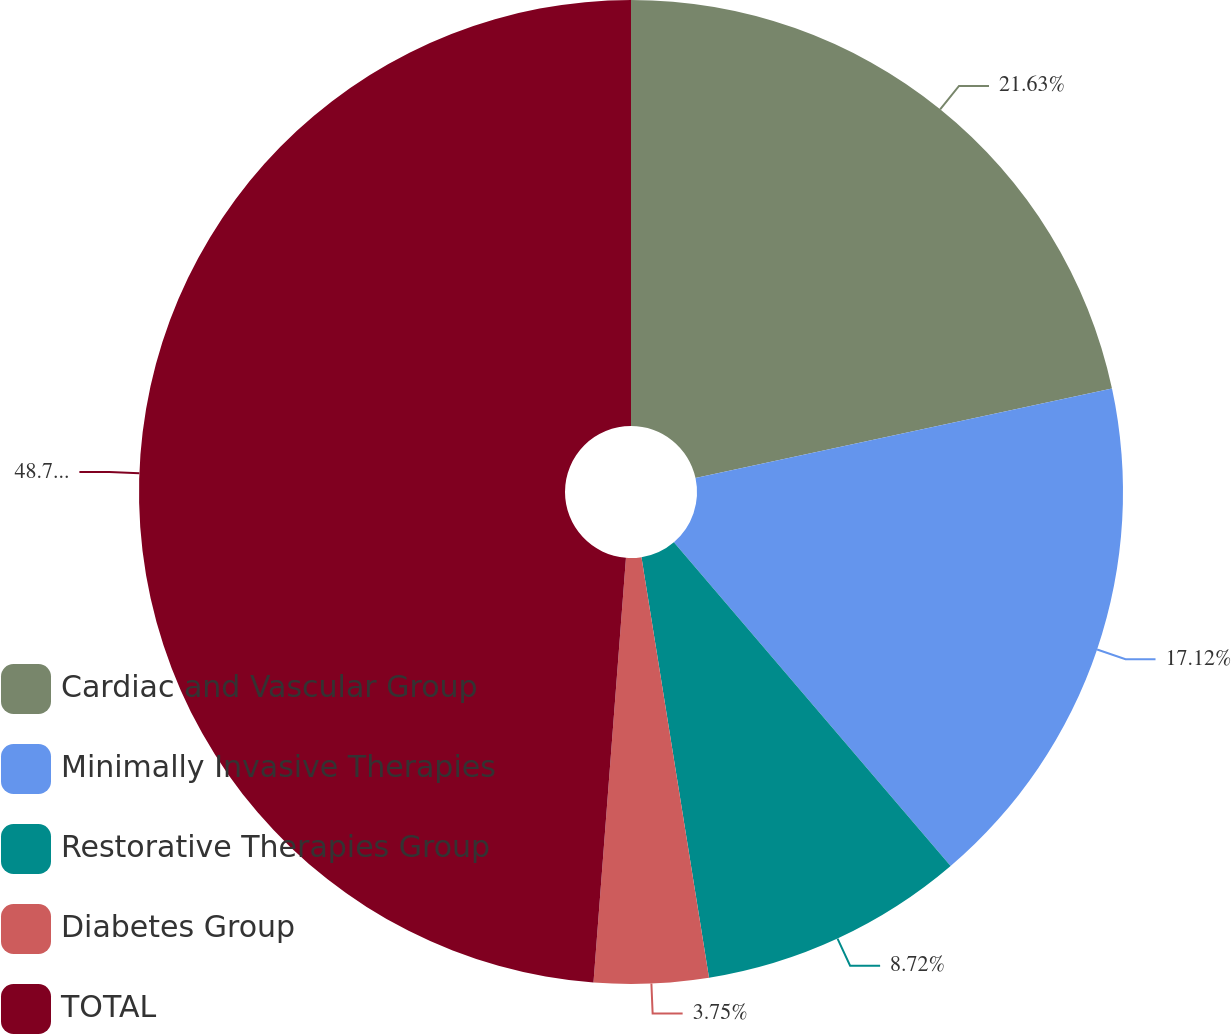Convert chart. <chart><loc_0><loc_0><loc_500><loc_500><pie_chart><fcel>Cardiac and Vascular Group<fcel>Minimally Invasive Therapies<fcel>Restorative Therapies Group<fcel>Diabetes Group<fcel>TOTAL<nl><fcel>21.63%<fcel>17.12%<fcel>8.72%<fcel>3.75%<fcel>48.79%<nl></chart> 